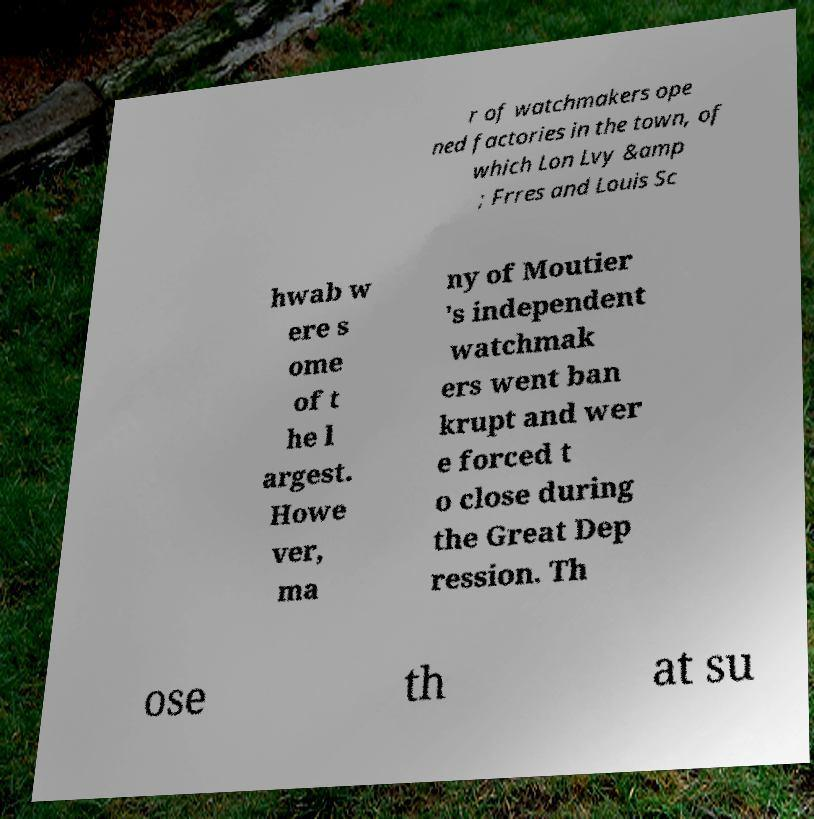I need the written content from this picture converted into text. Can you do that? r of watchmakers ope ned factories in the town, of which Lon Lvy &amp ; Frres and Louis Sc hwab w ere s ome of t he l argest. Howe ver, ma ny of Moutier 's independent watchmak ers went ban krupt and wer e forced t o close during the Great Dep ression. Th ose th at su 